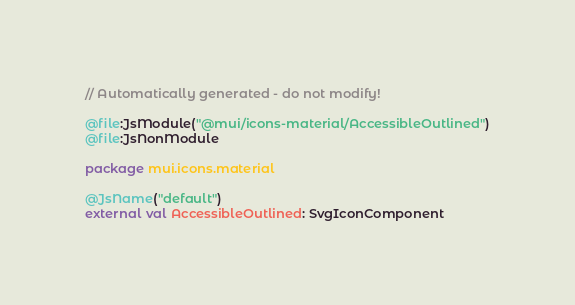<code> <loc_0><loc_0><loc_500><loc_500><_Kotlin_>// Automatically generated - do not modify!

@file:JsModule("@mui/icons-material/AccessibleOutlined")
@file:JsNonModule

package mui.icons.material

@JsName("default")
external val AccessibleOutlined: SvgIconComponent
</code> 